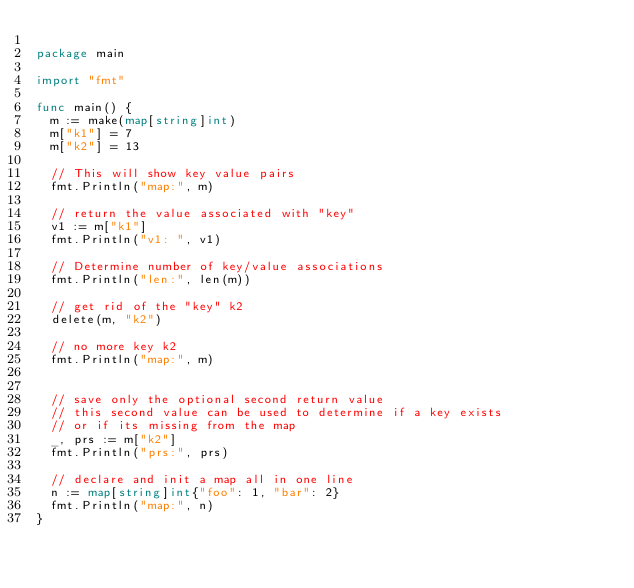Convert code to text. <code><loc_0><loc_0><loc_500><loc_500><_Go_>
package main

import "fmt"

func main() {
	m := make(map[string]int)
	m["k1"] = 7
	m["k2"] = 13

	// This will show key value pairs
	fmt.Println("map:", m)

	// return the value associated with "key"
	v1 := m["k1"]
	fmt.Println("v1: ", v1)

	// Determine number of key/value associations
	fmt.Println("len:", len(m))

	// get rid of the "key" k2
	delete(m, "k2")

	// no more key k2
	fmt.Println("map:", m)


	// save only the optional second return value
	// this second value can be used to determine if a key exists
	// or if its missing from the map
	_, prs := m["k2"]
	fmt.Println("prs:", prs)

	// declare and init a map all in one line
	n := map[string]int{"foo": 1, "bar": 2}
	fmt.Println("map:", n)
}
</code> 